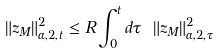<formula> <loc_0><loc_0><loc_500><loc_500>\| z _ { M } \| _ { \alpha , 2 , t } ^ { 2 } \leq R \int _ { 0 } ^ { t } d \tau \ \| z _ { M } \| _ { \alpha , 2 , \tau } ^ { 2 } \</formula> 